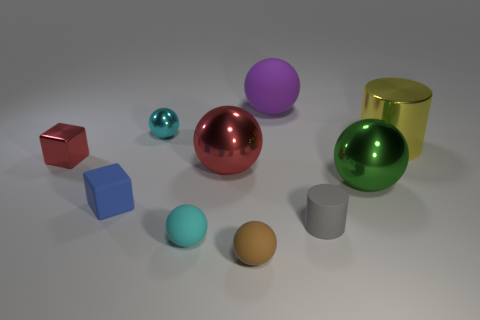Subtract 2 balls. How many balls are left? 4 Subtract all green spheres. How many spheres are left? 5 Subtract all cyan metallic balls. How many balls are left? 5 Subtract all yellow balls. Subtract all brown cylinders. How many balls are left? 6 Subtract all cubes. How many objects are left? 8 Add 3 tiny blue shiny cubes. How many tiny blue shiny cubes exist? 3 Subtract 0 green cylinders. How many objects are left? 10 Subtract all purple spheres. Subtract all purple blocks. How many objects are left? 9 Add 1 tiny red metal objects. How many tiny red metal objects are left? 2 